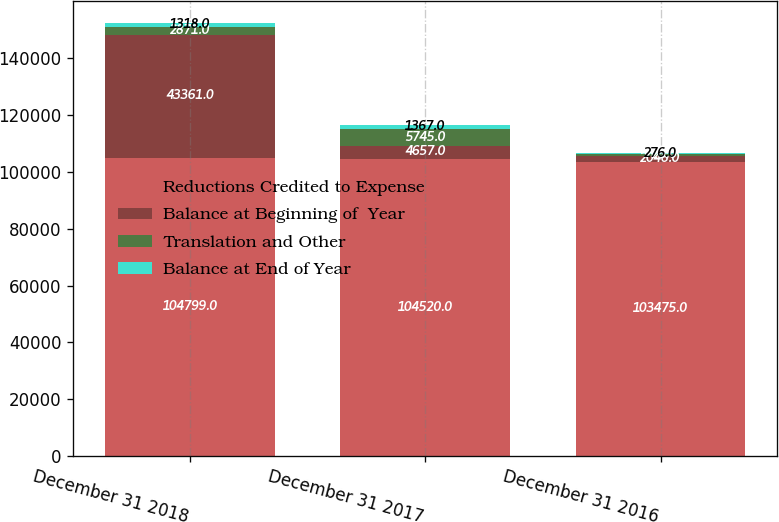Convert chart. <chart><loc_0><loc_0><loc_500><loc_500><stacked_bar_chart><ecel><fcel>December 31 2018<fcel>December 31 2017<fcel>December 31 2016<nl><fcel>Reductions Credited to Expense<fcel>104799<fcel>104520<fcel>103475<nl><fcel>Balance at Beginning of  Year<fcel>43361<fcel>4657<fcel>2046<nl><fcel>Translation and Other<fcel>2871<fcel>5745<fcel>725<nl><fcel>Balance at End of Year<fcel>1318<fcel>1367<fcel>276<nl></chart> 